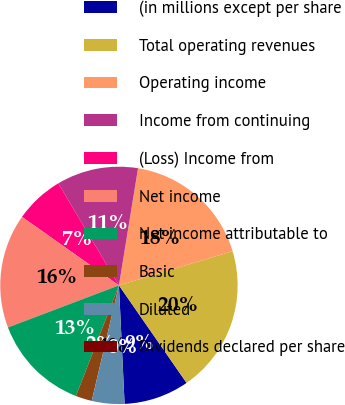Convert chart to OTSL. <chart><loc_0><loc_0><loc_500><loc_500><pie_chart><fcel>(in millions except per share<fcel>Total operating revenues<fcel>Operating income<fcel>Income from continuing<fcel>(Loss) Income from<fcel>Net income<fcel>Net income attributable to<fcel>Basic<fcel>Diluted<fcel>Dividends declared per share<nl><fcel>8.89%<fcel>20.0%<fcel>17.78%<fcel>11.11%<fcel>6.67%<fcel>15.56%<fcel>13.33%<fcel>2.22%<fcel>4.44%<fcel>0.0%<nl></chart> 